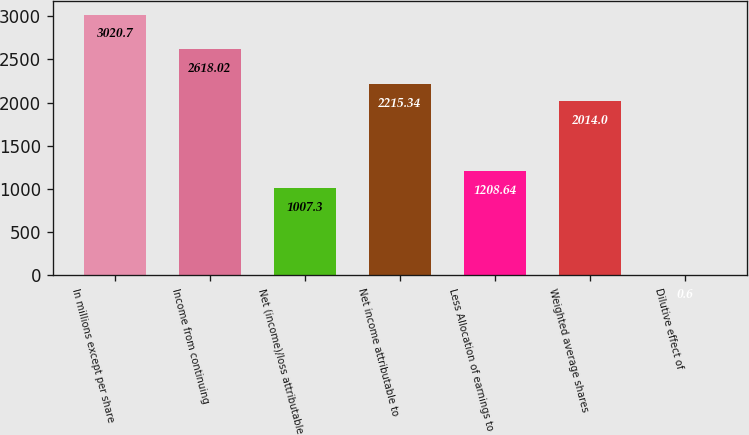Convert chart. <chart><loc_0><loc_0><loc_500><loc_500><bar_chart><fcel>In millions except per share<fcel>Income from continuing<fcel>Net (income)/loss attributable<fcel>Net income attributable to<fcel>Less Allocation of earnings to<fcel>Weighted average shares<fcel>Dilutive effect of<nl><fcel>3020.7<fcel>2618.02<fcel>1007.3<fcel>2215.34<fcel>1208.64<fcel>2014<fcel>0.6<nl></chart> 